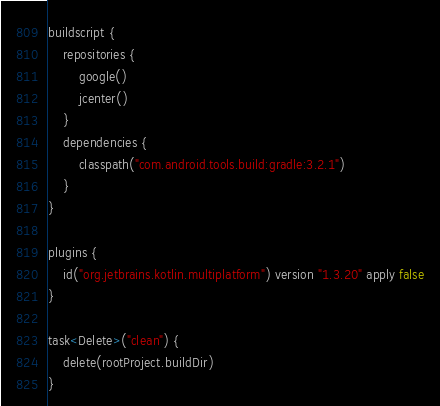<code> <loc_0><loc_0><loc_500><loc_500><_Kotlin_>buildscript {
    repositories {
        google()
        jcenter()
    }
    dependencies {
        classpath("com.android.tools.build:gradle:3.2.1")
    }
}

plugins {
    id("org.jetbrains.kotlin.multiplatform") version "1.3.20" apply false
}

task<Delete>("clean") {
    delete(rootProject.buildDir)
}
</code> 